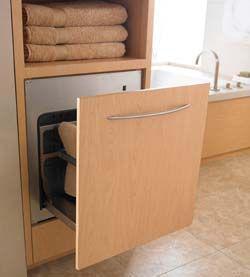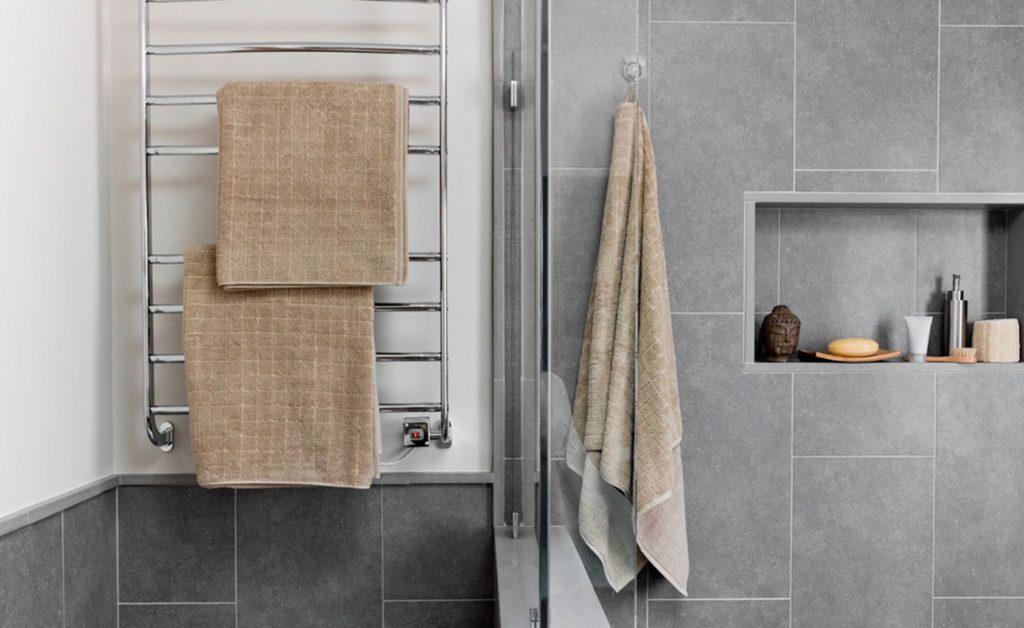The first image is the image on the left, the second image is the image on the right. For the images displayed, is the sentence "In at least one image there is an open drawer holding towels." factually correct? Answer yes or no. Yes. The first image is the image on the left, the second image is the image on the right. Assess this claim about the two images: "The left image shows a pull-out drawer containing towels, with a long horizontal handle on the drawer.". Correct or not? Answer yes or no. Yes. 